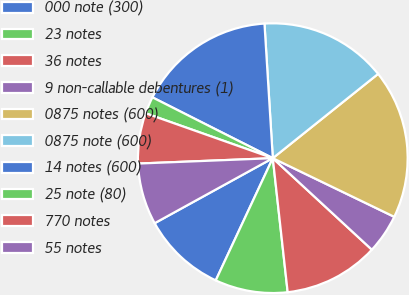Convert chart. <chart><loc_0><loc_0><loc_500><loc_500><pie_chart><fcel>000 note (300)<fcel>23 notes<fcel>36 notes<fcel>9 non-callable debentures (1)<fcel>0875 notes (600)<fcel>0875 note (600)<fcel>14 notes (600)<fcel>25 note (80)<fcel>770 notes<fcel>55 notes<nl><fcel>10.04%<fcel>8.71%<fcel>11.37%<fcel>4.71%<fcel>17.9%<fcel>15.24%<fcel>16.57%<fcel>2.04%<fcel>6.04%<fcel>7.37%<nl></chart> 